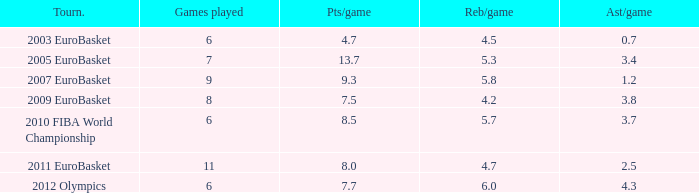How many points per game have the tournament 2005 eurobasket? 13.7. 